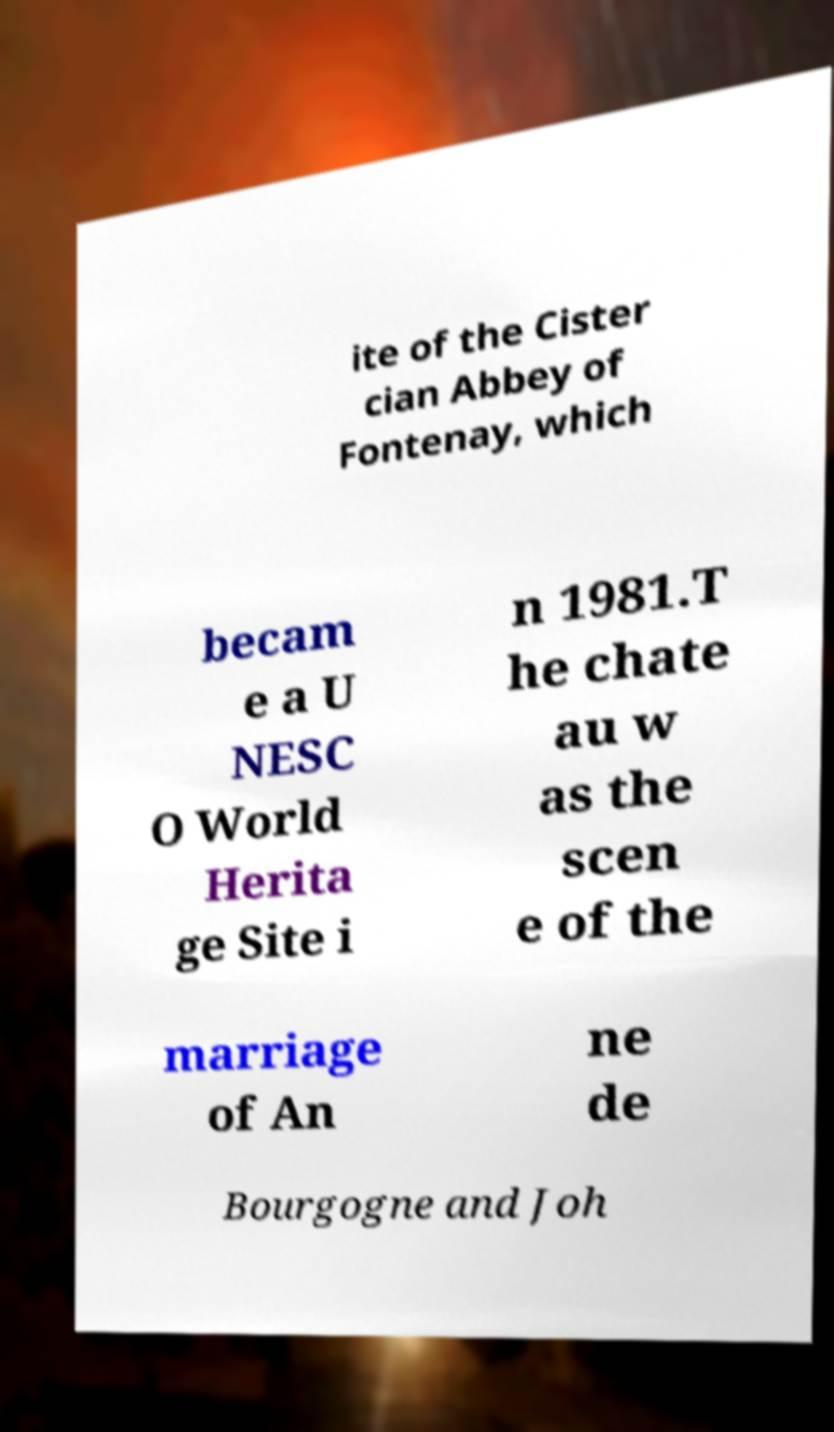Can you read and provide the text displayed in the image?This photo seems to have some interesting text. Can you extract and type it out for me? ite of the Cister cian Abbey of Fontenay, which becam e a U NESC O World Herita ge Site i n 1981.T he chate au w as the scen e of the marriage of An ne de Bourgogne and Joh 